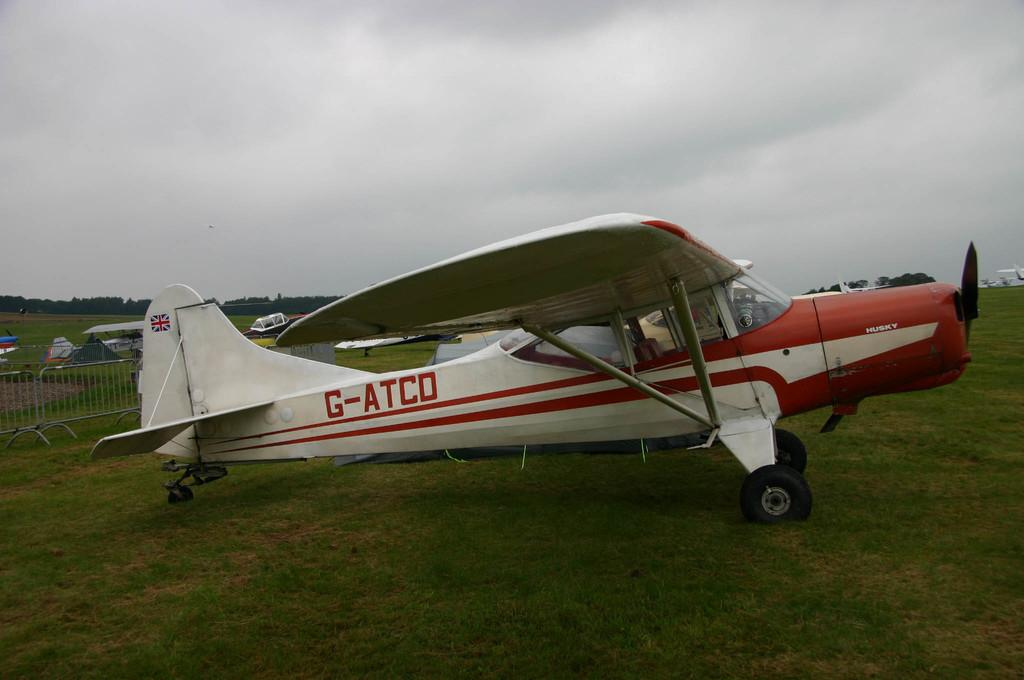Provide a one-sentence caption for the provided image. A small red and white plane with call sign G-ATCO. 